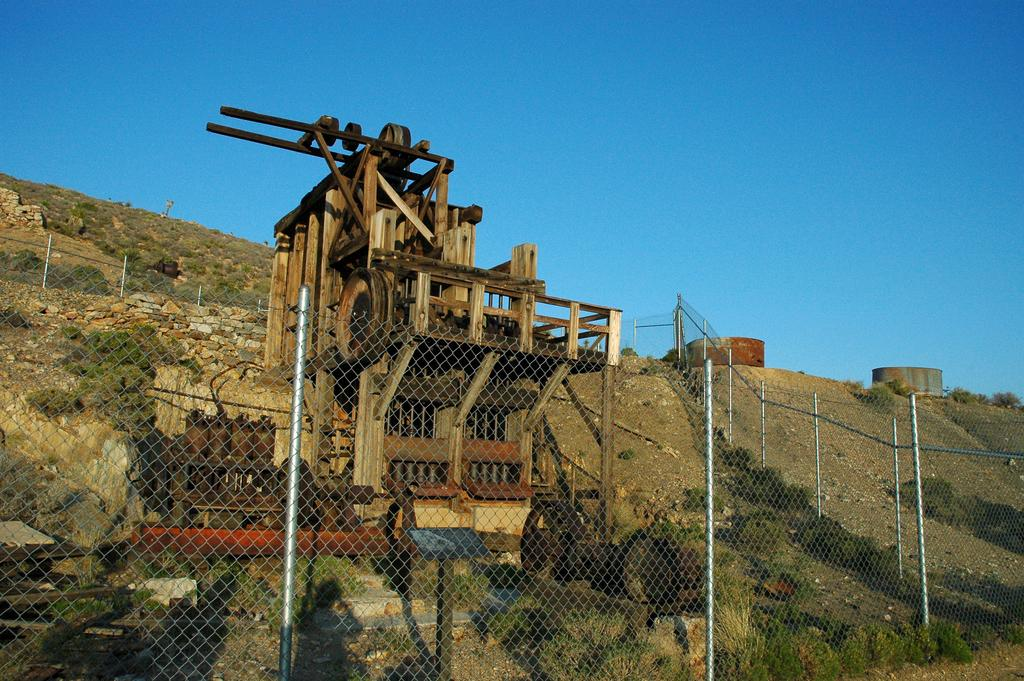What is the main object in the image? There is a machine in the image. What else can be seen in the image besides the machine? There are stones, plants, a fence, and poles in the image. What is the background of the image? The sky is visible in the background of the image. What note is the machine playing in the image? There is no indication in the image that the machine is playing a note or producing any sound. 